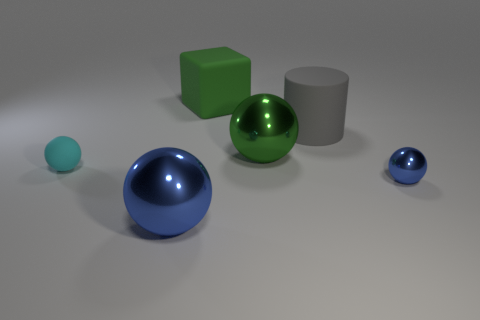Is the number of blue spheres that are in front of the tiny blue metal sphere greater than the number of large brown cubes? No, there is only one blue sphere in front of the tiny blue metal sphere, while there are two large brown cubes present in the image. 